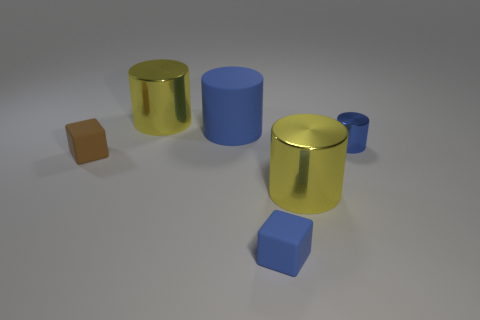What color is the rubber thing that is the same shape as the tiny blue metal thing?
Provide a short and direct response. Blue. Do the rubber cube in front of the brown matte thing and the blue metal cylinder have the same size?
Your response must be concise. Yes. How big is the yellow metal object on the left side of the big yellow thing in front of the tiny blue metal thing?
Make the answer very short. Large. Are the big blue cylinder and the tiny blue object in front of the tiny cylinder made of the same material?
Your answer should be compact. Yes. Is the number of blue cylinders in front of the big blue rubber object less than the number of brown cubes on the left side of the tiny blue cylinder?
Ensure brevity in your answer.  No. The cylinder that is made of the same material as the blue cube is what color?
Ensure brevity in your answer.  Blue. There is a metal object that is in front of the tiny shiny object; is there a tiny shiny object that is in front of it?
Offer a very short reply. No. There is a cylinder that is the same size as the blue cube; what color is it?
Keep it short and to the point. Blue. How many objects are either gray cubes or tiny blue rubber objects?
Offer a terse response. 1. There is a yellow object that is in front of the brown matte object behind the yellow cylinder that is in front of the small brown object; what size is it?
Make the answer very short. Large. 